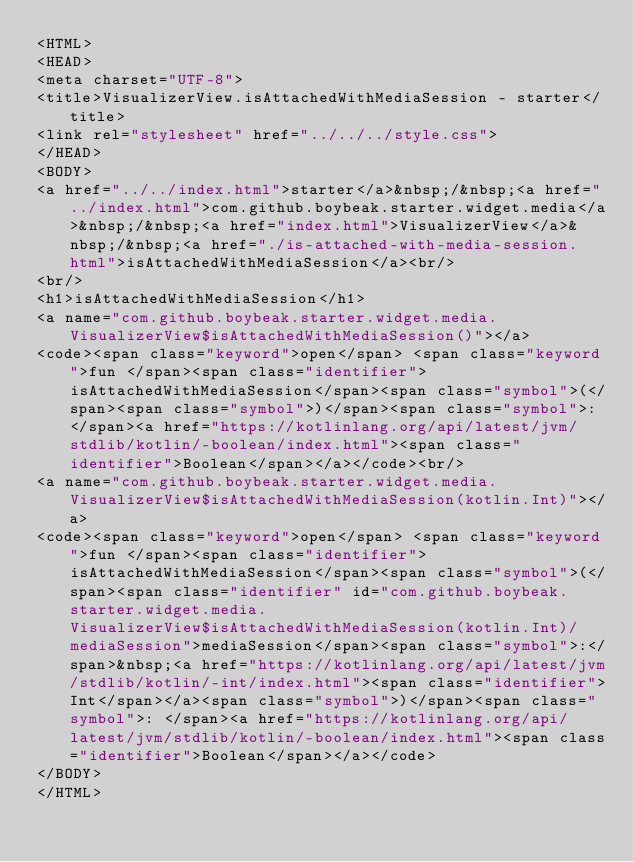<code> <loc_0><loc_0><loc_500><loc_500><_HTML_><HTML>
<HEAD>
<meta charset="UTF-8">
<title>VisualizerView.isAttachedWithMediaSession - starter</title>
<link rel="stylesheet" href="../../../style.css">
</HEAD>
<BODY>
<a href="../../index.html">starter</a>&nbsp;/&nbsp;<a href="../index.html">com.github.boybeak.starter.widget.media</a>&nbsp;/&nbsp;<a href="index.html">VisualizerView</a>&nbsp;/&nbsp;<a href="./is-attached-with-media-session.html">isAttachedWithMediaSession</a><br/>
<br/>
<h1>isAttachedWithMediaSession</h1>
<a name="com.github.boybeak.starter.widget.media.VisualizerView$isAttachedWithMediaSession()"></a>
<code><span class="keyword">open</span> <span class="keyword">fun </span><span class="identifier">isAttachedWithMediaSession</span><span class="symbol">(</span><span class="symbol">)</span><span class="symbol">: </span><a href="https://kotlinlang.org/api/latest/jvm/stdlib/kotlin/-boolean/index.html"><span class="identifier">Boolean</span></a></code><br/>
<a name="com.github.boybeak.starter.widget.media.VisualizerView$isAttachedWithMediaSession(kotlin.Int)"></a>
<code><span class="keyword">open</span> <span class="keyword">fun </span><span class="identifier">isAttachedWithMediaSession</span><span class="symbol">(</span><span class="identifier" id="com.github.boybeak.starter.widget.media.VisualizerView$isAttachedWithMediaSession(kotlin.Int)/mediaSession">mediaSession</span><span class="symbol">:</span>&nbsp;<a href="https://kotlinlang.org/api/latest/jvm/stdlib/kotlin/-int/index.html"><span class="identifier">Int</span></a><span class="symbol">)</span><span class="symbol">: </span><a href="https://kotlinlang.org/api/latest/jvm/stdlib/kotlin/-boolean/index.html"><span class="identifier">Boolean</span></a></code>
</BODY>
</HTML>
</code> 